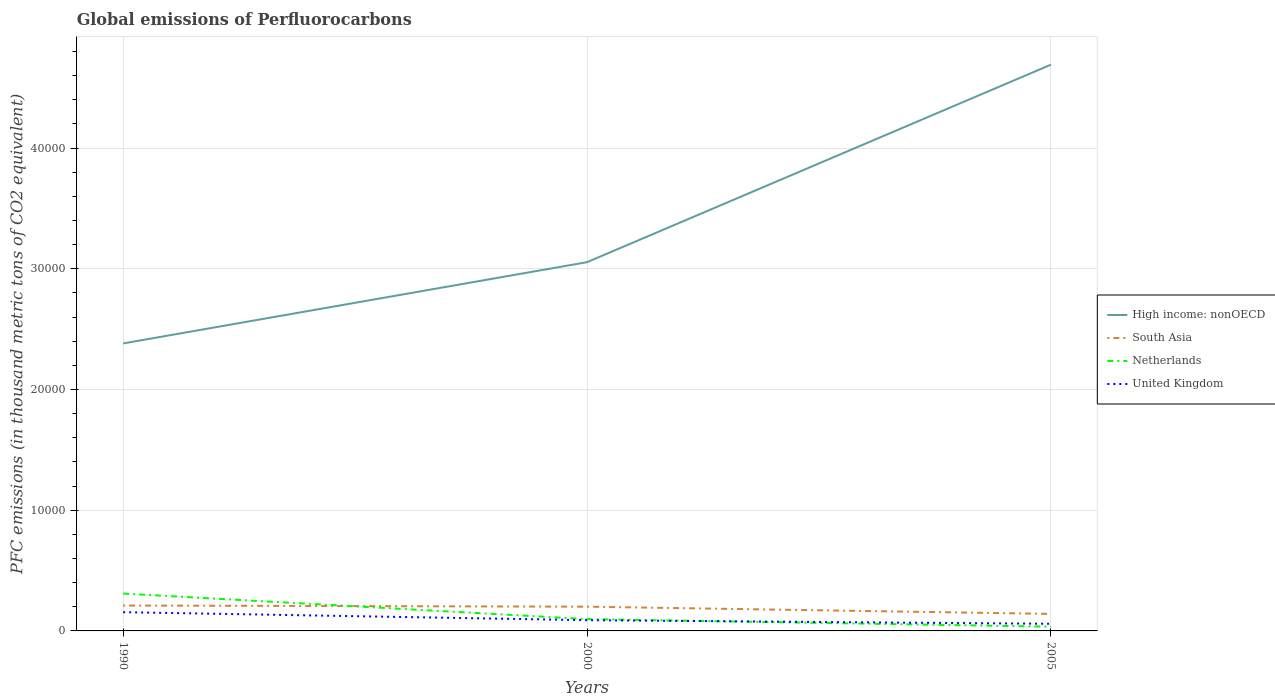How many different coloured lines are there?
Keep it short and to the point. 4. Across all years, what is the maximum global emissions of Perfluorocarbons in South Asia?
Provide a succinct answer. 1410.84. In which year was the global emissions of Perfluorocarbons in High income: nonOECD maximum?
Give a very brief answer. 1990. What is the total global emissions of Perfluorocarbons in United Kingdom in the graph?
Offer a terse response. 961.1. What is the difference between the highest and the second highest global emissions of Perfluorocarbons in High income: nonOECD?
Give a very brief answer. 2.31e+04. What is the difference between the highest and the lowest global emissions of Perfluorocarbons in Netherlands?
Ensure brevity in your answer.  1. How many lines are there?
Offer a terse response. 4. How many years are there in the graph?
Make the answer very short. 3. What is the difference between two consecutive major ticks on the Y-axis?
Provide a succinct answer. 10000. Does the graph contain grids?
Offer a very short reply. Yes. How are the legend labels stacked?
Your answer should be compact. Vertical. What is the title of the graph?
Your answer should be very brief. Global emissions of Perfluorocarbons. What is the label or title of the Y-axis?
Keep it short and to the point. PFC emissions (in thousand metric tons of CO2 equivalent). What is the PFC emissions (in thousand metric tons of CO2 equivalent) of High income: nonOECD in 1990?
Offer a terse response. 2.38e+04. What is the PFC emissions (in thousand metric tons of CO2 equivalent) in South Asia in 1990?
Offer a very short reply. 2104. What is the PFC emissions (in thousand metric tons of CO2 equivalent) of Netherlands in 1990?
Ensure brevity in your answer.  3096.2. What is the PFC emissions (in thousand metric tons of CO2 equivalent) of United Kingdom in 1990?
Your answer should be compact. 1552.5. What is the PFC emissions (in thousand metric tons of CO2 equivalent) in High income: nonOECD in 2000?
Provide a succinct answer. 3.06e+04. What is the PFC emissions (in thousand metric tons of CO2 equivalent) in South Asia in 2000?
Provide a short and direct response. 2008.8. What is the PFC emissions (in thousand metric tons of CO2 equivalent) of Netherlands in 2000?
Keep it short and to the point. 979.5. What is the PFC emissions (in thousand metric tons of CO2 equivalent) of United Kingdom in 2000?
Provide a succinct answer. 890.1. What is the PFC emissions (in thousand metric tons of CO2 equivalent) in High income: nonOECD in 2005?
Keep it short and to the point. 4.69e+04. What is the PFC emissions (in thousand metric tons of CO2 equivalent) in South Asia in 2005?
Offer a very short reply. 1410.84. What is the PFC emissions (in thousand metric tons of CO2 equivalent) in Netherlands in 2005?
Make the answer very short. 351.4. What is the PFC emissions (in thousand metric tons of CO2 equivalent) in United Kingdom in 2005?
Your response must be concise. 591.4. Across all years, what is the maximum PFC emissions (in thousand metric tons of CO2 equivalent) of High income: nonOECD?
Your answer should be very brief. 4.69e+04. Across all years, what is the maximum PFC emissions (in thousand metric tons of CO2 equivalent) in South Asia?
Make the answer very short. 2104. Across all years, what is the maximum PFC emissions (in thousand metric tons of CO2 equivalent) in Netherlands?
Make the answer very short. 3096.2. Across all years, what is the maximum PFC emissions (in thousand metric tons of CO2 equivalent) of United Kingdom?
Your answer should be compact. 1552.5. Across all years, what is the minimum PFC emissions (in thousand metric tons of CO2 equivalent) of High income: nonOECD?
Offer a very short reply. 2.38e+04. Across all years, what is the minimum PFC emissions (in thousand metric tons of CO2 equivalent) of South Asia?
Your answer should be compact. 1410.84. Across all years, what is the minimum PFC emissions (in thousand metric tons of CO2 equivalent) of Netherlands?
Give a very brief answer. 351.4. Across all years, what is the minimum PFC emissions (in thousand metric tons of CO2 equivalent) of United Kingdom?
Ensure brevity in your answer.  591.4. What is the total PFC emissions (in thousand metric tons of CO2 equivalent) of High income: nonOECD in the graph?
Your answer should be compact. 1.01e+05. What is the total PFC emissions (in thousand metric tons of CO2 equivalent) in South Asia in the graph?
Ensure brevity in your answer.  5523.64. What is the total PFC emissions (in thousand metric tons of CO2 equivalent) of Netherlands in the graph?
Ensure brevity in your answer.  4427.1. What is the total PFC emissions (in thousand metric tons of CO2 equivalent) in United Kingdom in the graph?
Give a very brief answer. 3034. What is the difference between the PFC emissions (in thousand metric tons of CO2 equivalent) of High income: nonOECD in 1990 and that in 2000?
Your response must be concise. -6731.3. What is the difference between the PFC emissions (in thousand metric tons of CO2 equivalent) of South Asia in 1990 and that in 2000?
Ensure brevity in your answer.  95.2. What is the difference between the PFC emissions (in thousand metric tons of CO2 equivalent) of Netherlands in 1990 and that in 2000?
Offer a very short reply. 2116.7. What is the difference between the PFC emissions (in thousand metric tons of CO2 equivalent) in United Kingdom in 1990 and that in 2000?
Offer a very short reply. 662.4. What is the difference between the PFC emissions (in thousand metric tons of CO2 equivalent) in High income: nonOECD in 1990 and that in 2005?
Your answer should be compact. -2.31e+04. What is the difference between the PFC emissions (in thousand metric tons of CO2 equivalent) of South Asia in 1990 and that in 2005?
Ensure brevity in your answer.  693.16. What is the difference between the PFC emissions (in thousand metric tons of CO2 equivalent) in Netherlands in 1990 and that in 2005?
Make the answer very short. 2744.8. What is the difference between the PFC emissions (in thousand metric tons of CO2 equivalent) in United Kingdom in 1990 and that in 2005?
Ensure brevity in your answer.  961.1. What is the difference between the PFC emissions (in thousand metric tons of CO2 equivalent) of High income: nonOECD in 2000 and that in 2005?
Make the answer very short. -1.64e+04. What is the difference between the PFC emissions (in thousand metric tons of CO2 equivalent) in South Asia in 2000 and that in 2005?
Provide a short and direct response. 597.96. What is the difference between the PFC emissions (in thousand metric tons of CO2 equivalent) in Netherlands in 2000 and that in 2005?
Offer a very short reply. 628.1. What is the difference between the PFC emissions (in thousand metric tons of CO2 equivalent) of United Kingdom in 2000 and that in 2005?
Make the answer very short. 298.7. What is the difference between the PFC emissions (in thousand metric tons of CO2 equivalent) of High income: nonOECD in 1990 and the PFC emissions (in thousand metric tons of CO2 equivalent) of South Asia in 2000?
Offer a terse response. 2.18e+04. What is the difference between the PFC emissions (in thousand metric tons of CO2 equivalent) in High income: nonOECD in 1990 and the PFC emissions (in thousand metric tons of CO2 equivalent) in Netherlands in 2000?
Make the answer very short. 2.28e+04. What is the difference between the PFC emissions (in thousand metric tons of CO2 equivalent) in High income: nonOECD in 1990 and the PFC emissions (in thousand metric tons of CO2 equivalent) in United Kingdom in 2000?
Provide a short and direct response. 2.29e+04. What is the difference between the PFC emissions (in thousand metric tons of CO2 equivalent) in South Asia in 1990 and the PFC emissions (in thousand metric tons of CO2 equivalent) in Netherlands in 2000?
Provide a succinct answer. 1124.5. What is the difference between the PFC emissions (in thousand metric tons of CO2 equivalent) in South Asia in 1990 and the PFC emissions (in thousand metric tons of CO2 equivalent) in United Kingdom in 2000?
Make the answer very short. 1213.9. What is the difference between the PFC emissions (in thousand metric tons of CO2 equivalent) in Netherlands in 1990 and the PFC emissions (in thousand metric tons of CO2 equivalent) in United Kingdom in 2000?
Provide a short and direct response. 2206.1. What is the difference between the PFC emissions (in thousand metric tons of CO2 equivalent) in High income: nonOECD in 1990 and the PFC emissions (in thousand metric tons of CO2 equivalent) in South Asia in 2005?
Your answer should be compact. 2.24e+04. What is the difference between the PFC emissions (in thousand metric tons of CO2 equivalent) of High income: nonOECD in 1990 and the PFC emissions (in thousand metric tons of CO2 equivalent) of Netherlands in 2005?
Keep it short and to the point. 2.35e+04. What is the difference between the PFC emissions (in thousand metric tons of CO2 equivalent) in High income: nonOECD in 1990 and the PFC emissions (in thousand metric tons of CO2 equivalent) in United Kingdom in 2005?
Ensure brevity in your answer.  2.32e+04. What is the difference between the PFC emissions (in thousand metric tons of CO2 equivalent) of South Asia in 1990 and the PFC emissions (in thousand metric tons of CO2 equivalent) of Netherlands in 2005?
Provide a short and direct response. 1752.6. What is the difference between the PFC emissions (in thousand metric tons of CO2 equivalent) of South Asia in 1990 and the PFC emissions (in thousand metric tons of CO2 equivalent) of United Kingdom in 2005?
Make the answer very short. 1512.6. What is the difference between the PFC emissions (in thousand metric tons of CO2 equivalent) of Netherlands in 1990 and the PFC emissions (in thousand metric tons of CO2 equivalent) of United Kingdom in 2005?
Provide a short and direct response. 2504.8. What is the difference between the PFC emissions (in thousand metric tons of CO2 equivalent) of High income: nonOECD in 2000 and the PFC emissions (in thousand metric tons of CO2 equivalent) of South Asia in 2005?
Keep it short and to the point. 2.91e+04. What is the difference between the PFC emissions (in thousand metric tons of CO2 equivalent) in High income: nonOECD in 2000 and the PFC emissions (in thousand metric tons of CO2 equivalent) in Netherlands in 2005?
Provide a short and direct response. 3.02e+04. What is the difference between the PFC emissions (in thousand metric tons of CO2 equivalent) of High income: nonOECD in 2000 and the PFC emissions (in thousand metric tons of CO2 equivalent) of United Kingdom in 2005?
Provide a short and direct response. 3.00e+04. What is the difference between the PFC emissions (in thousand metric tons of CO2 equivalent) in South Asia in 2000 and the PFC emissions (in thousand metric tons of CO2 equivalent) in Netherlands in 2005?
Keep it short and to the point. 1657.4. What is the difference between the PFC emissions (in thousand metric tons of CO2 equivalent) in South Asia in 2000 and the PFC emissions (in thousand metric tons of CO2 equivalent) in United Kingdom in 2005?
Offer a terse response. 1417.4. What is the difference between the PFC emissions (in thousand metric tons of CO2 equivalent) in Netherlands in 2000 and the PFC emissions (in thousand metric tons of CO2 equivalent) in United Kingdom in 2005?
Offer a very short reply. 388.1. What is the average PFC emissions (in thousand metric tons of CO2 equivalent) in High income: nonOECD per year?
Provide a short and direct response. 3.38e+04. What is the average PFC emissions (in thousand metric tons of CO2 equivalent) of South Asia per year?
Ensure brevity in your answer.  1841.21. What is the average PFC emissions (in thousand metric tons of CO2 equivalent) in Netherlands per year?
Provide a succinct answer. 1475.7. What is the average PFC emissions (in thousand metric tons of CO2 equivalent) in United Kingdom per year?
Provide a short and direct response. 1011.33. In the year 1990, what is the difference between the PFC emissions (in thousand metric tons of CO2 equivalent) in High income: nonOECD and PFC emissions (in thousand metric tons of CO2 equivalent) in South Asia?
Ensure brevity in your answer.  2.17e+04. In the year 1990, what is the difference between the PFC emissions (in thousand metric tons of CO2 equivalent) of High income: nonOECD and PFC emissions (in thousand metric tons of CO2 equivalent) of Netherlands?
Ensure brevity in your answer.  2.07e+04. In the year 1990, what is the difference between the PFC emissions (in thousand metric tons of CO2 equivalent) in High income: nonOECD and PFC emissions (in thousand metric tons of CO2 equivalent) in United Kingdom?
Offer a very short reply. 2.23e+04. In the year 1990, what is the difference between the PFC emissions (in thousand metric tons of CO2 equivalent) in South Asia and PFC emissions (in thousand metric tons of CO2 equivalent) in Netherlands?
Offer a terse response. -992.2. In the year 1990, what is the difference between the PFC emissions (in thousand metric tons of CO2 equivalent) in South Asia and PFC emissions (in thousand metric tons of CO2 equivalent) in United Kingdom?
Give a very brief answer. 551.5. In the year 1990, what is the difference between the PFC emissions (in thousand metric tons of CO2 equivalent) in Netherlands and PFC emissions (in thousand metric tons of CO2 equivalent) in United Kingdom?
Keep it short and to the point. 1543.7. In the year 2000, what is the difference between the PFC emissions (in thousand metric tons of CO2 equivalent) in High income: nonOECD and PFC emissions (in thousand metric tons of CO2 equivalent) in South Asia?
Give a very brief answer. 2.85e+04. In the year 2000, what is the difference between the PFC emissions (in thousand metric tons of CO2 equivalent) in High income: nonOECD and PFC emissions (in thousand metric tons of CO2 equivalent) in Netherlands?
Provide a short and direct response. 2.96e+04. In the year 2000, what is the difference between the PFC emissions (in thousand metric tons of CO2 equivalent) of High income: nonOECD and PFC emissions (in thousand metric tons of CO2 equivalent) of United Kingdom?
Offer a terse response. 2.97e+04. In the year 2000, what is the difference between the PFC emissions (in thousand metric tons of CO2 equivalent) of South Asia and PFC emissions (in thousand metric tons of CO2 equivalent) of Netherlands?
Your answer should be very brief. 1029.3. In the year 2000, what is the difference between the PFC emissions (in thousand metric tons of CO2 equivalent) of South Asia and PFC emissions (in thousand metric tons of CO2 equivalent) of United Kingdom?
Provide a succinct answer. 1118.7. In the year 2000, what is the difference between the PFC emissions (in thousand metric tons of CO2 equivalent) in Netherlands and PFC emissions (in thousand metric tons of CO2 equivalent) in United Kingdom?
Your response must be concise. 89.4. In the year 2005, what is the difference between the PFC emissions (in thousand metric tons of CO2 equivalent) in High income: nonOECD and PFC emissions (in thousand metric tons of CO2 equivalent) in South Asia?
Give a very brief answer. 4.55e+04. In the year 2005, what is the difference between the PFC emissions (in thousand metric tons of CO2 equivalent) of High income: nonOECD and PFC emissions (in thousand metric tons of CO2 equivalent) of Netherlands?
Give a very brief answer. 4.66e+04. In the year 2005, what is the difference between the PFC emissions (in thousand metric tons of CO2 equivalent) in High income: nonOECD and PFC emissions (in thousand metric tons of CO2 equivalent) in United Kingdom?
Keep it short and to the point. 4.63e+04. In the year 2005, what is the difference between the PFC emissions (in thousand metric tons of CO2 equivalent) in South Asia and PFC emissions (in thousand metric tons of CO2 equivalent) in Netherlands?
Provide a short and direct response. 1059.44. In the year 2005, what is the difference between the PFC emissions (in thousand metric tons of CO2 equivalent) of South Asia and PFC emissions (in thousand metric tons of CO2 equivalent) of United Kingdom?
Provide a succinct answer. 819.44. In the year 2005, what is the difference between the PFC emissions (in thousand metric tons of CO2 equivalent) in Netherlands and PFC emissions (in thousand metric tons of CO2 equivalent) in United Kingdom?
Provide a short and direct response. -240. What is the ratio of the PFC emissions (in thousand metric tons of CO2 equivalent) of High income: nonOECD in 1990 to that in 2000?
Give a very brief answer. 0.78. What is the ratio of the PFC emissions (in thousand metric tons of CO2 equivalent) of South Asia in 1990 to that in 2000?
Provide a short and direct response. 1.05. What is the ratio of the PFC emissions (in thousand metric tons of CO2 equivalent) in Netherlands in 1990 to that in 2000?
Keep it short and to the point. 3.16. What is the ratio of the PFC emissions (in thousand metric tons of CO2 equivalent) of United Kingdom in 1990 to that in 2000?
Provide a succinct answer. 1.74. What is the ratio of the PFC emissions (in thousand metric tons of CO2 equivalent) in High income: nonOECD in 1990 to that in 2005?
Your answer should be compact. 0.51. What is the ratio of the PFC emissions (in thousand metric tons of CO2 equivalent) in South Asia in 1990 to that in 2005?
Offer a very short reply. 1.49. What is the ratio of the PFC emissions (in thousand metric tons of CO2 equivalent) in Netherlands in 1990 to that in 2005?
Give a very brief answer. 8.81. What is the ratio of the PFC emissions (in thousand metric tons of CO2 equivalent) in United Kingdom in 1990 to that in 2005?
Offer a terse response. 2.63. What is the ratio of the PFC emissions (in thousand metric tons of CO2 equivalent) in High income: nonOECD in 2000 to that in 2005?
Make the answer very short. 0.65. What is the ratio of the PFC emissions (in thousand metric tons of CO2 equivalent) in South Asia in 2000 to that in 2005?
Provide a succinct answer. 1.42. What is the ratio of the PFC emissions (in thousand metric tons of CO2 equivalent) in Netherlands in 2000 to that in 2005?
Offer a terse response. 2.79. What is the ratio of the PFC emissions (in thousand metric tons of CO2 equivalent) in United Kingdom in 2000 to that in 2005?
Give a very brief answer. 1.51. What is the difference between the highest and the second highest PFC emissions (in thousand metric tons of CO2 equivalent) in High income: nonOECD?
Ensure brevity in your answer.  1.64e+04. What is the difference between the highest and the second highest PFC emissions (in thousand metric tons of CO2 equivalent) of South Asia?
Provide a succinct answer. 95.2. What is the difference between the highest and the second highest PFC emissions (in thousand metric tons of CO2 equivalent) in Netherlands?
Your answer should be compact. 2116.7. What is the difference between the highest and the second highest PFC emissions (in thousand metric tons of CO2 equivalent) in United Kingdom?
Your answer should be compact. 662.4. What is the difference between the highest and the lowest PFC emissions (in thousand metric tons of CO2 equivalent) in High income: nonOECD?
Provide a succinct answer. 2.31e+04. What is the difference between the highest and the lowest PFC emissions (in thousand metric tons of CO2 equivalent) in South Asia?
Offer a very short reply. 693.16. What is the difference between the highest and the lowest PFC emissions (in thousand metric tons of CO2 equivalent) in Netherlands?
Make the answer very short. 2744.8. What is the difference between the highest and the lowest PFC emissions (in thousand metric tons of CO2 equivalent) in United Kingdom?
Keep it short and to the point. 961.1. 